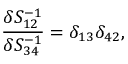<formula> <loc_0><loc_0><loc_500><loc_500>\frac { \delta S _ { 1 2 } ^ { - 1 } } { \delta S _ { 3 4 } ^ { - 1 } } = \delta _ { 1 3 } \delta _ { 4 2 } ,</formula> 